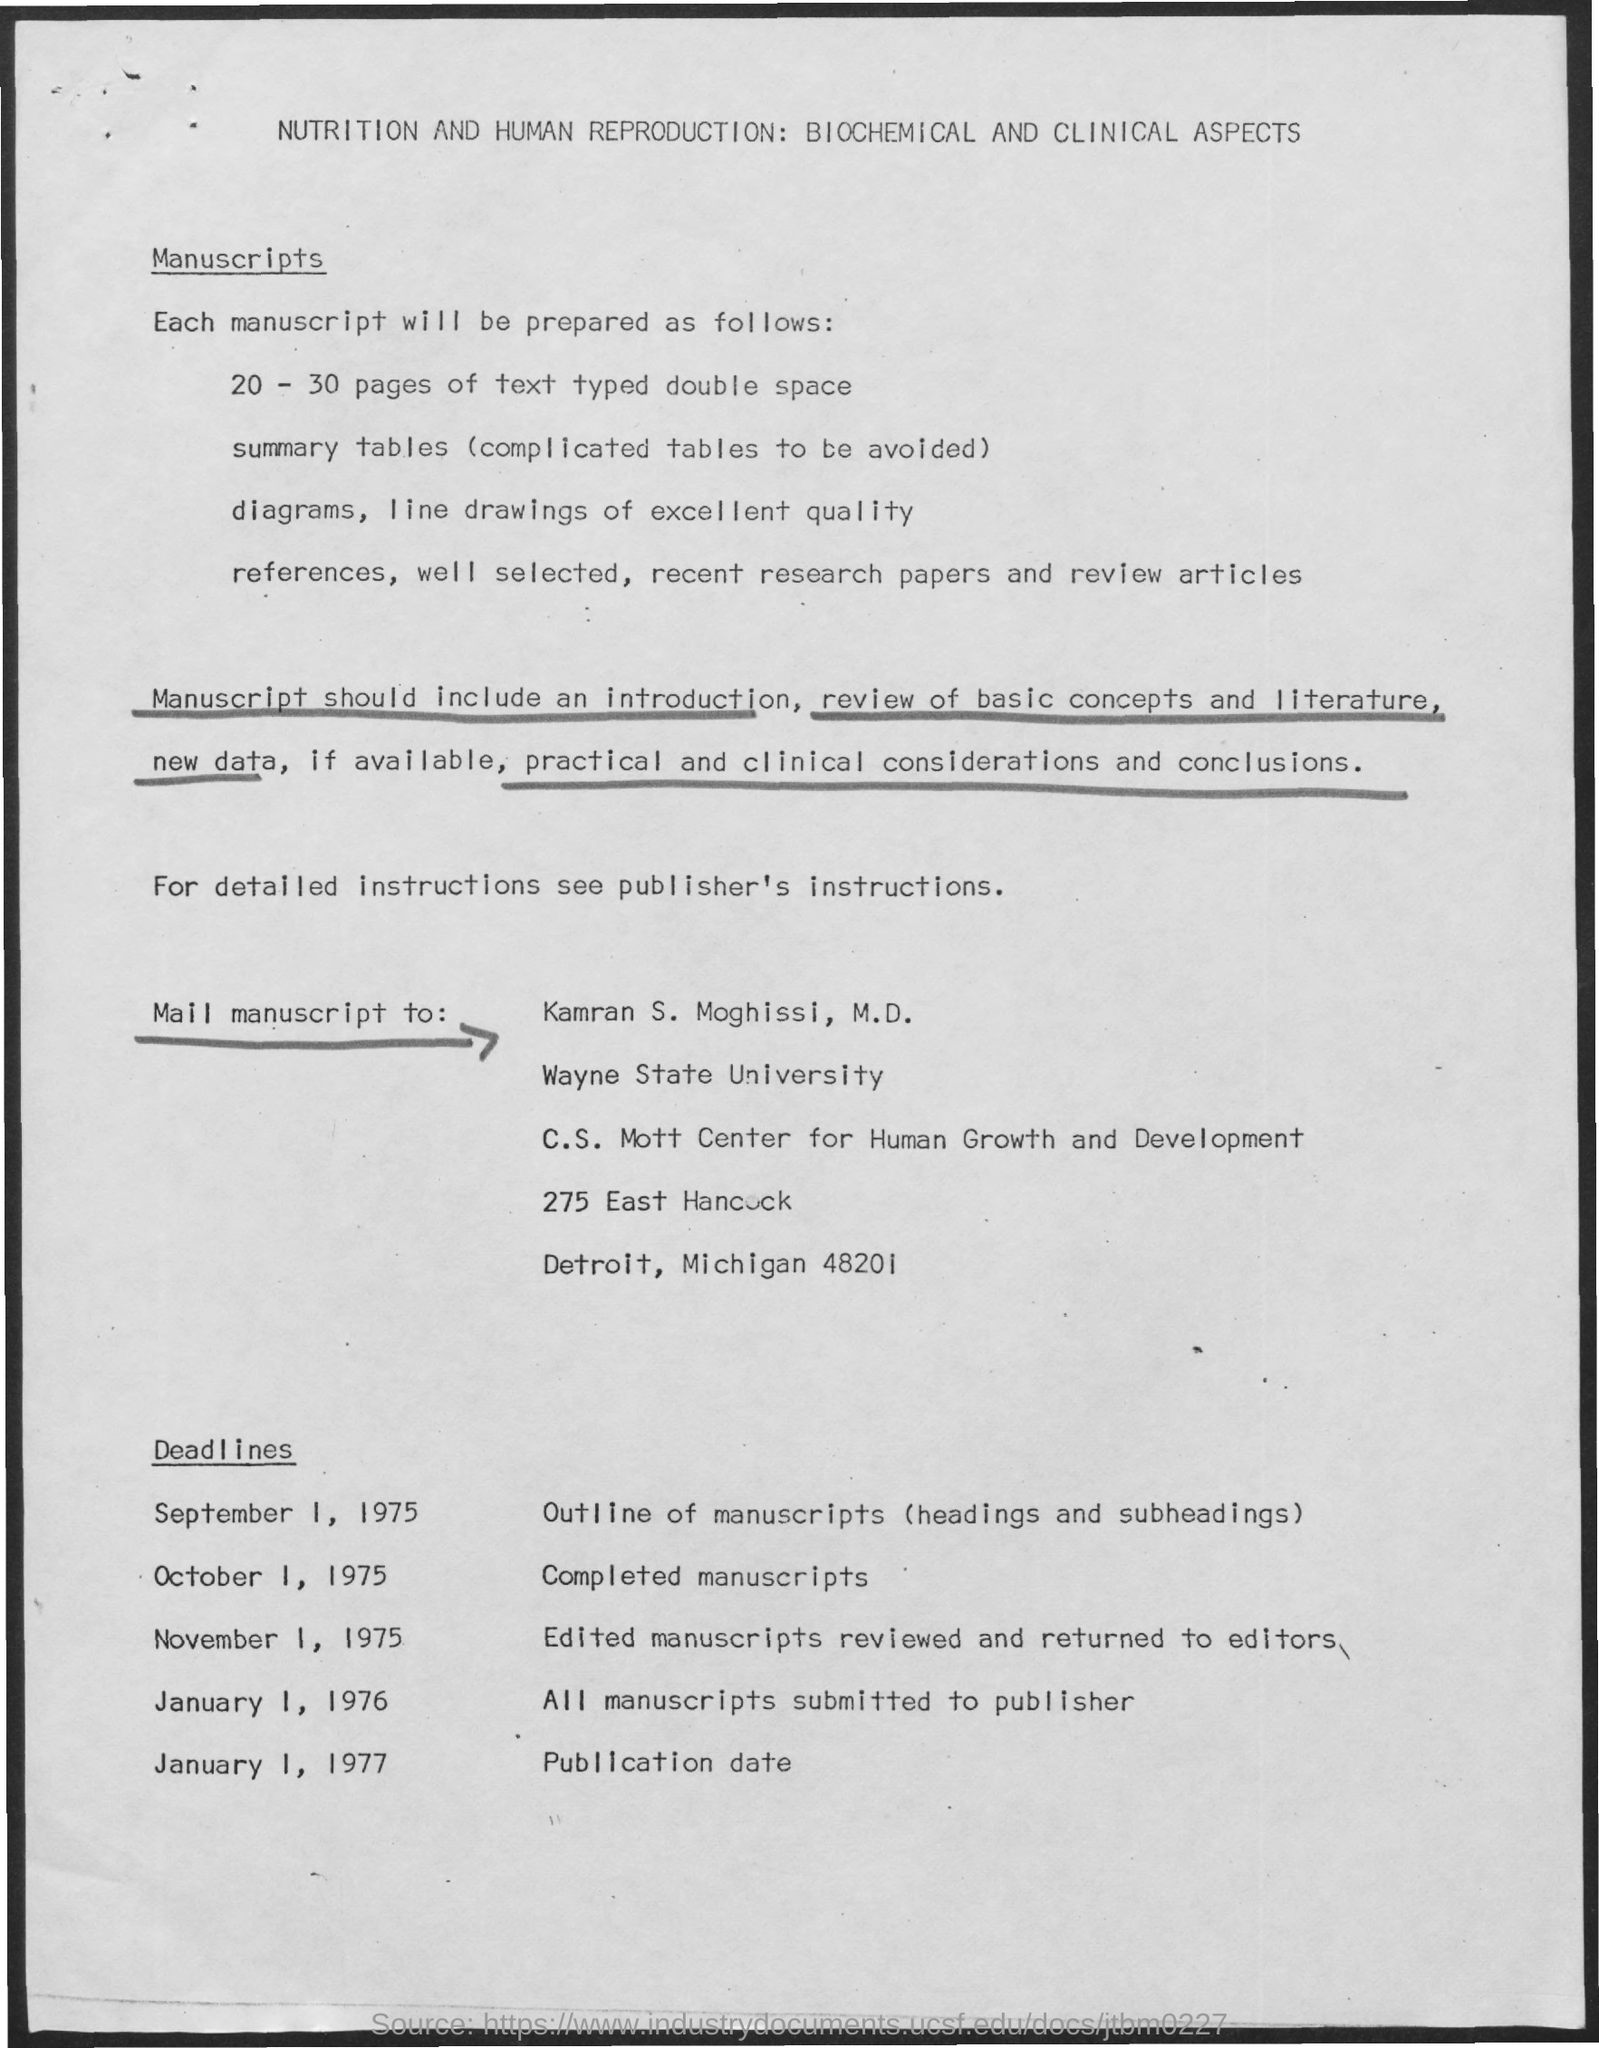What is the deadline for Completed Manuscripts?
Your response must be concise. October 1, 1975. What is publication date mentioned in the document?
Offer a terse response. January 1, 1977. What is the deadline for outline of manuscripts (heading and subheadings)?
Your answer should be very brief. September 1, 1975. To whom, the manuscript should be mailed?
Give a very brief answer. Kamran S. Moghissi, M.D. What is the deadline for all manuscripts submitted to publisher?
Keep it short and to the point. January 1, 1976. Kamran S. Moghissi, M.D. is from which university?
Offer a terse response. Wayne State University. 